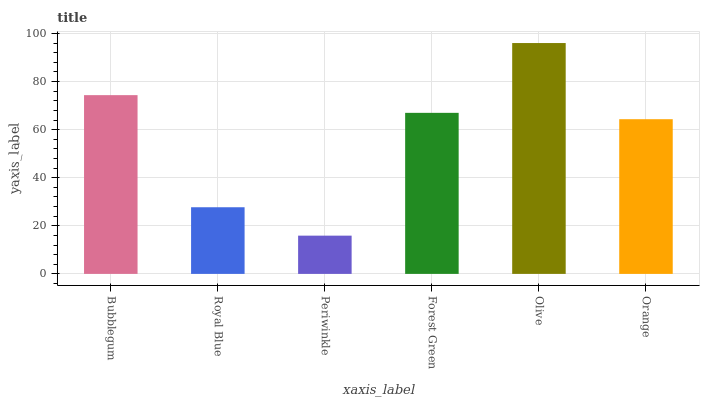Is Periwinkle the minimum?
Answer yes or no. Yes. Is Olive the maximum?
Answer yes or no. Yes. Is Royal Blue the minimum?
Answer yes or no. No. Is Royal Blue the maximum?
Answer yes or no. No. Is Bubblegum greater than Royal Blue?
Answer yes or no. Yes. Is Royal Blue less than Bubblegum?
Answer yes or no. Yes. Is Royal Blue greater than Bubblegum?
Answer yes or no. No. Is Bubblegum less than Royal Blue?
Answer yes or no. No. Is Forest Green the high median?
Answer yes or no. Yes. Is Orange the low median?
Answer yes or no. Yes. Is Olive the high median?
Answer yes or no. No. Is Olive the low median?
Answer yes or no. No. 